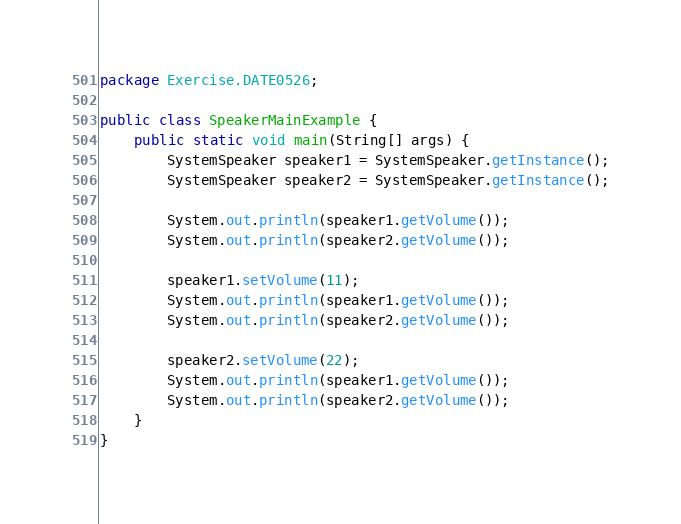Convert code to text. <code><loc_0><loc_0><loc_500><loc_500><_Java_>package Exercise.DATE0526;

public class SpeakerMainExample {
	public static void main(String[] args) {
		SystemSpeaker speaker1 = SystemSpeaker.getInstance();
		SystemSpeaker speaker2 = SystemSpeaker.getInstance();
		
		System.out.println(speaker1.getVolume());
		System.out.println(speaker2.getVolume());
		
		speaker1.setVolume(11);
		System.out.println(speaker1.getVolume());
		System.out.println(speaker2.getVolume());
		
		speaker2.setVolume(22);
		System.out.println(speaker1.getVolume());
		System.out.println(speaker2.getVolume());
	}
}</code> 